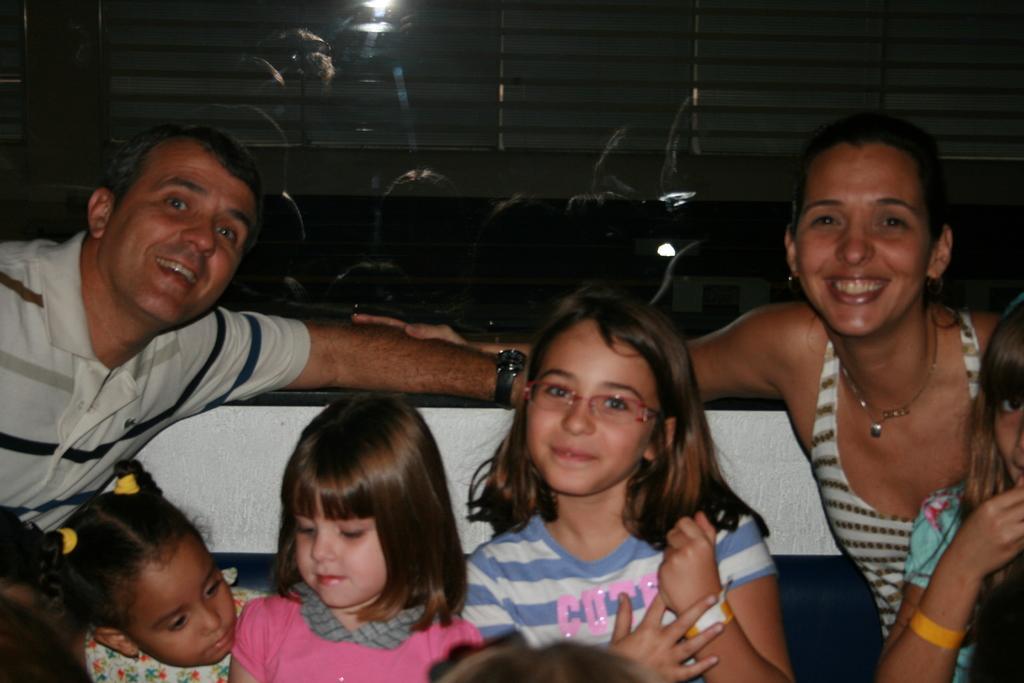Describe this image in one or two sentences. In this image we can see a few people sitting on the couch, also we can see reflections of those people in the mirror, and there is a light. 